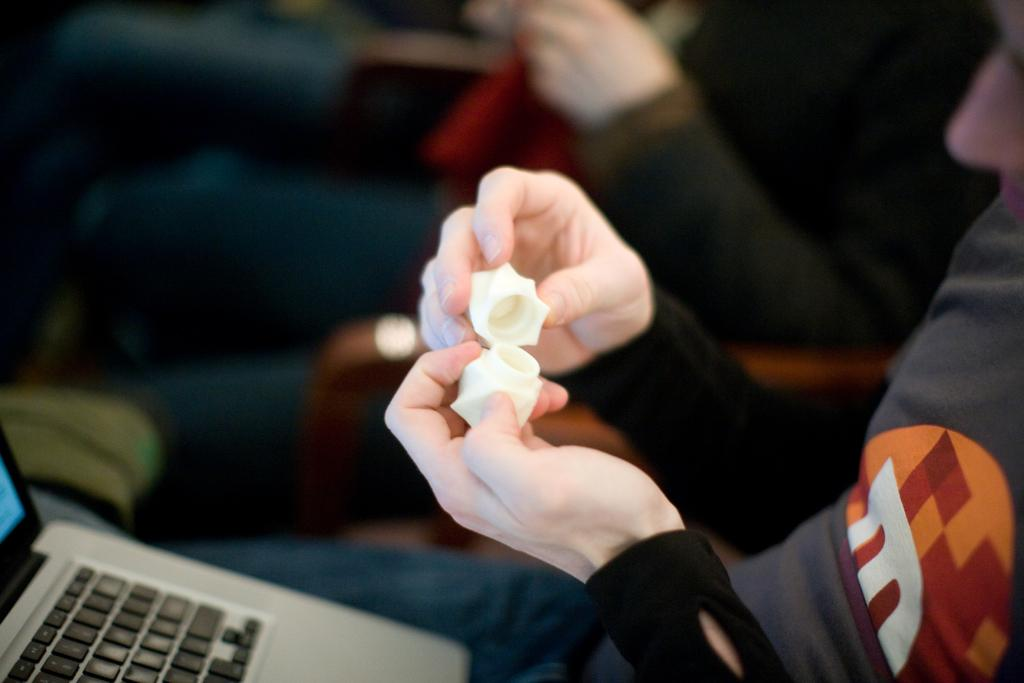What are the people in the image doing? The people in the image are sitting. What are the people holding in their hands? The people are holding something in their hands, but the image does not specify what it is. Can you describe any objects in the image besides the people? Yes, there is a laptop in the bottom left corner of the image. What type of honey is being collected by the goose in the image? There is no goose or honey present in the image. What kind of stone is being used as a paperweight on the laptop? There is no stone or paperweight visible on the laptop in the image. 